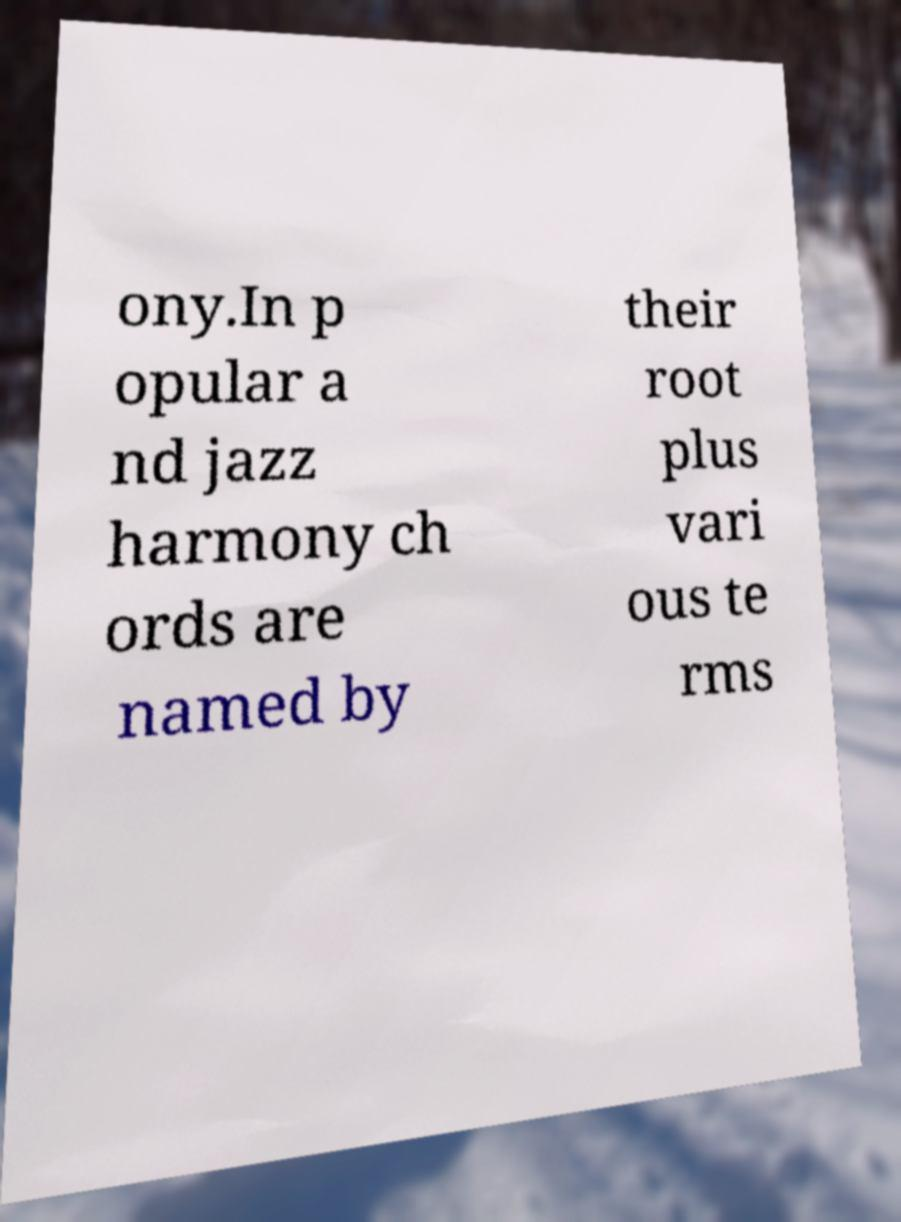Can you read and provide the text displayed in the image?This photo seems to have some interesting text. Can you extract and type it out for me? ony.In p opular a nd jazz harmony ch ords are named by their root plus vari ous te rms 